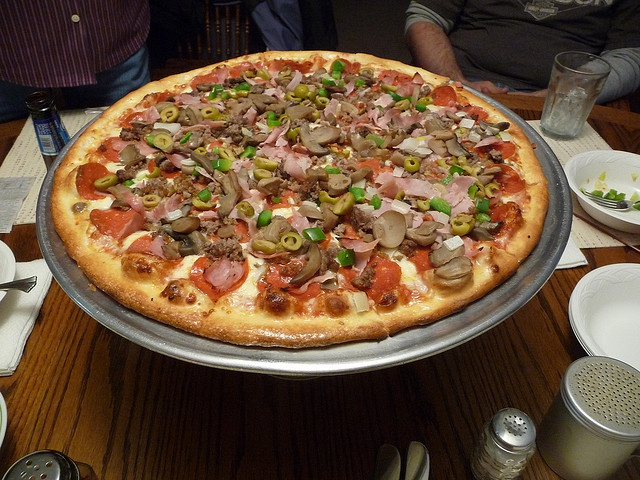Describe the objects in this image and their specific colors. I can see dining table in black, maroon, brown, and gray tones, pizza in black, brown, gray, tan, and maroon tones, people in black, gray, brown, and maroon tones, people in black and darkblue tones, and bowl in black, lightgray, and darkgray tones in this image. 